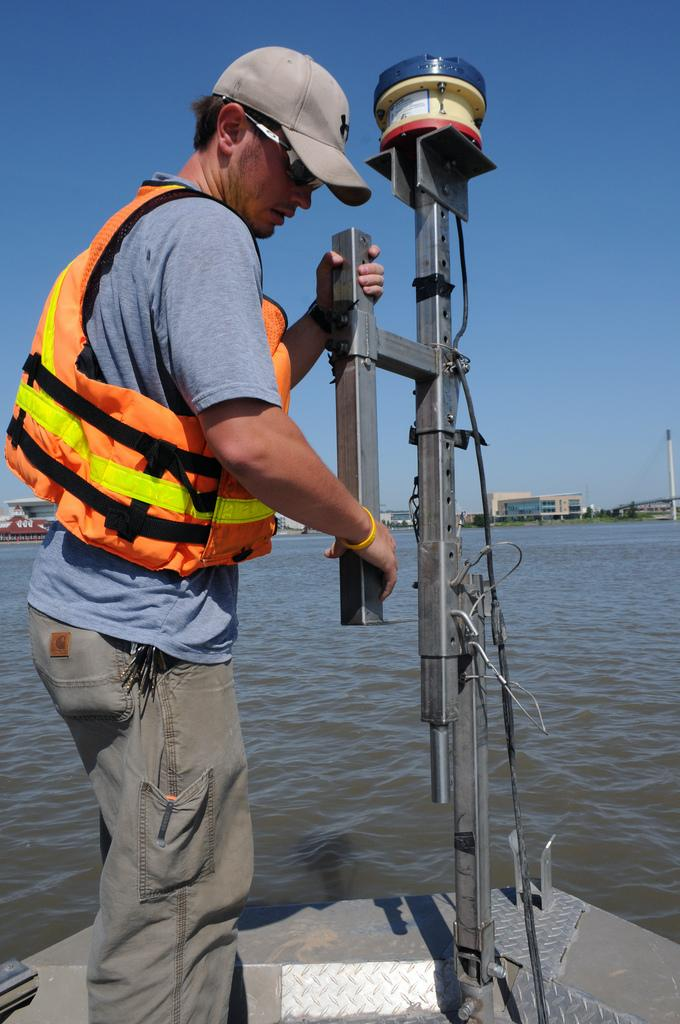What is there is a man standing on a boat in the image, what is he doing? The man is standing on a boat in the image. What can be seen in the background of the image? There is water, buildings, and the sky visible in the background of the image. Can you see a bomb exploding in the image? No, there is no bomb or explosion present in the image. Is there a tiger swimming in the water next to the boat? No, there is no tiger visible in the image. 